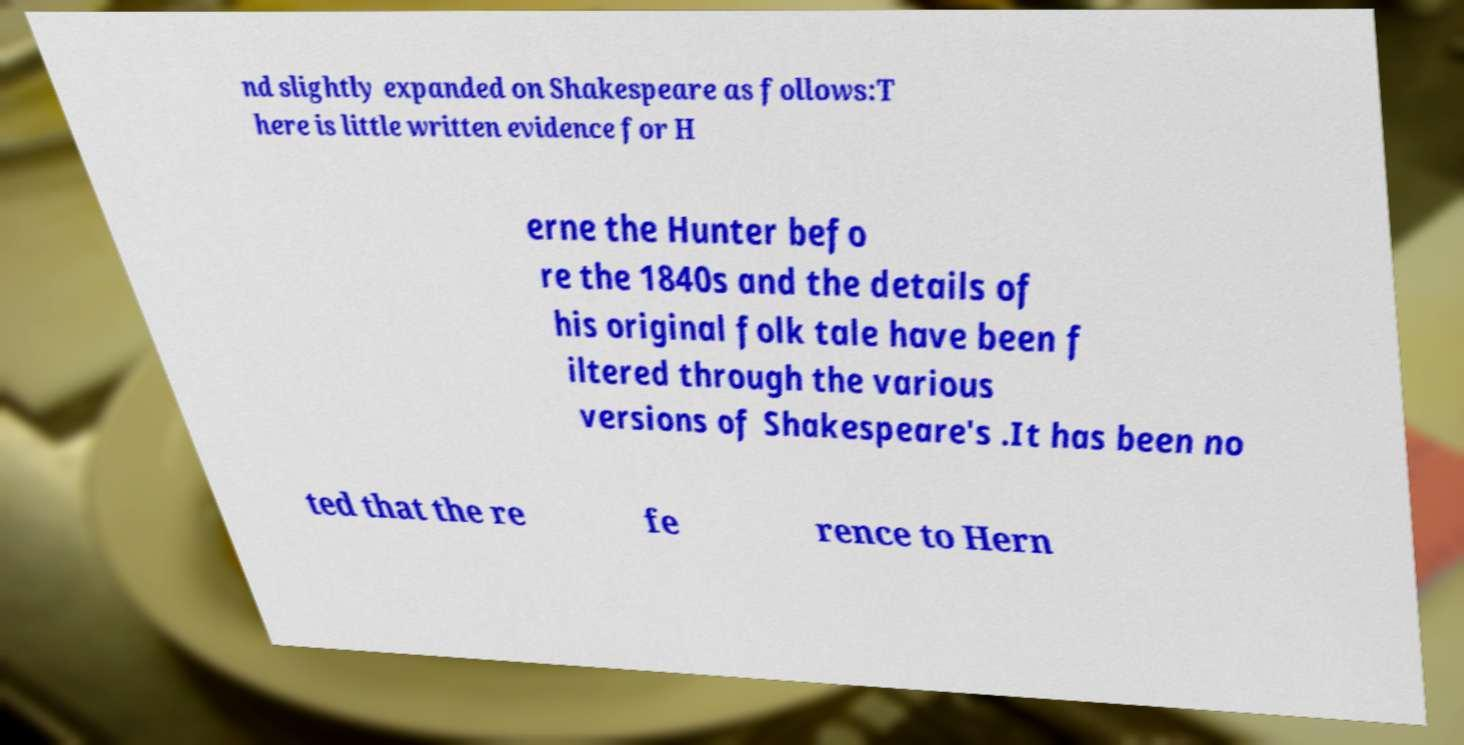Could you assist in decoding the text presented in this image and type it out clearly? nd slightly expanded on Shakespeare as follows:T here is little written evidence for H erne the Hunter befo re the 1840s and the details of his original folk tale have been f iltered through the various versions of Shakespeare's .It has been no ted that the re fe rence to Hern 